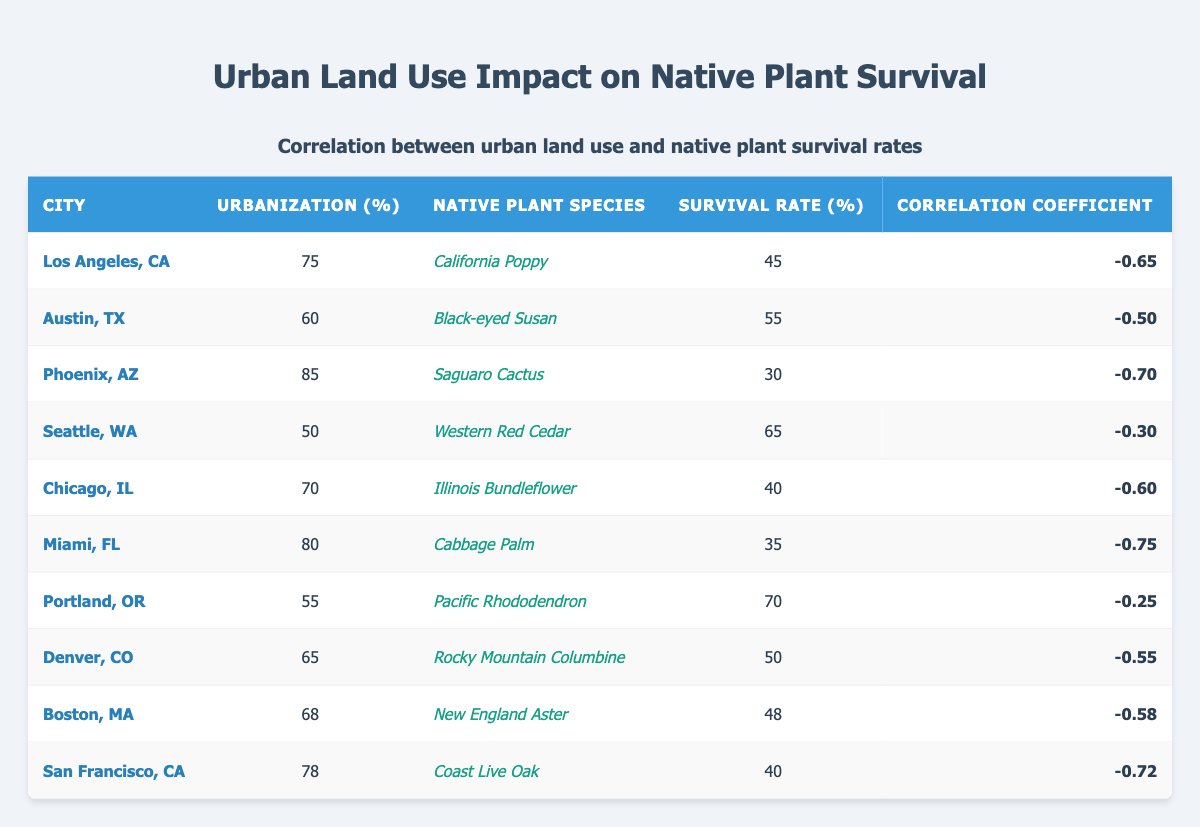What's the urbanization percentage for Phoenix, AZ? The table indicates that Phoenix, AZ has an urbanization percentage of 85%.
Answer: 85 Which city has the highest native plant survival rate? By comparing the survival rates listed in the table, Seattle, WA has the highest survival rate at 65%.
Answer: Seattle, WA What is the correlation coefficient for Miami, FL? The table shows that the correlation coefficient for Miami, FL is -0.75.
Answer: -0.75 How many cities have a native plant survival rate below 50%? Checking the survival rates, the cities with rates below 50% are Los Angeles (45), Phoenix (30), Chicago (40), Miami (35), and San Francisco (40), totaling 5 cities.
Answer: 5 What is the average survival rate of all the cities listed? To find the average, sum all the survival rates (45 + 55 + 30 + 65 + 40 + 35 + 70 + 50 + 48 + 40 =  478) and divide by the number of cities (10). Therefore, 478/10 = 47.8.
Answer: 47.8 Is the claim that urbanization affects native plant survival rates generally true based on the correlation coefficients? Yes, all correlation coefficients are negative, indicating that as urbanization increases, survival rates tend to decrease.
Answer: Yes Which city has the lowest survival rate and what is that rate? Looking through the survival rates, Miami, FL has the lowest survival rate at 35%.
Answer: Miami, FL; 35 What is the median urbanization percentage across all cities? Arranging the urbanization percentages in ascending order: 50, 55, 60, 65, 68, 70, 75, 78, 80, 85. The median is the average of the 5th and 6th values (68 and 70), (68 + 70) / 2 = 69.
Answer: 69 Which native plant species has the highest survival rate and how does it rank among the urbanization percentage? The Pacific Rhododendron has the highest survival rate of 70% and ranks 2nd lowest in urbanization percentage (55%) compared to the other species listed.
Answer: Pacific Rhododendron; 70 Calculate the difference in survival rates between the best and worst performing cities. The best survival rate is from Seattle (65), and the worst is from Phoenix (30). The difference is 65 - 30 = 35.
Answer: 35 